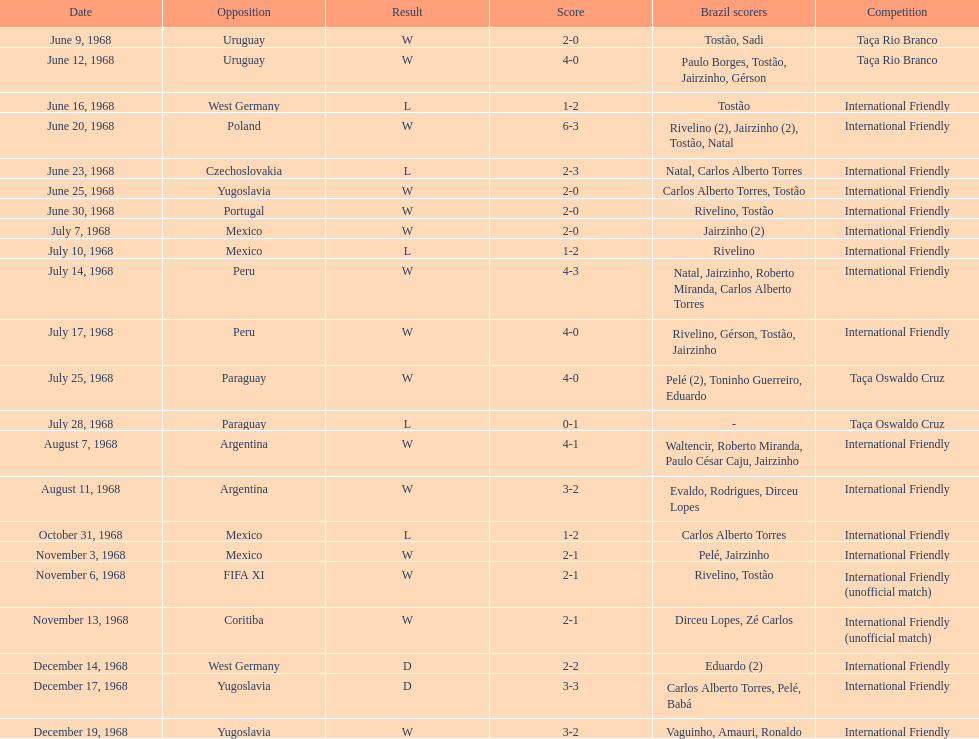Overall amount of triumphs 15. Could you parse the entire table? {'header': ['Date', 'Opposition', 'Result', 'Score', 'Brazil scorers', 'Competition'], 'rows': [['June 9, 1968', 'Uruguay', 'W', '2-0', 'Tostão, Sadi', 'Taça Rio Branco'], ['June 12, 1968', 'Uruguay', 'W', '4-0', 'Paulo Borges, Tostão, Jairzinho, Gérson', 'Taça Rio Branco'], ['June 16, 1968', 'West Germany', 'L', '1-2', 'Tostão', 'International Friendly'], ['June 20, 1968', 'Poland', 'W', '6-3', 'Rivelino (2), Jairzinho (2), Tostão, Natal', 'International Friendly'], ['June 23, 1968', 'Czechoslovakia', 'L', '2-3', 'Natal, Carlos Alberto Torres', 'International Friendly'], ['June 25, 1968', 'Yugoslavia', 'W', '2-0', 'Carlos Alberto Torres, Tostão', 'International Friendly'], ['June 30, 1968', 'Portugal', 'W', '2-0', 'Rivelino, Tostão', 'International Friendly'], ['July 7, 1968', 'Mexico', 'W', '2-0', 'Jairzinho (2)', 'International Friendly'], ['July 10, 1968', 'Mexico', 'L', '1-2', 'Rivelino', 'International Friendly'], ['July 14, 1968', 'Peru', 'W', '4-3', 'Natal, Jairzinho, Roberto Miranda, Carlos Alberto Torres', 'International Friendly'], ['July 17, 1968', 'Peru', 'W', '4-0', 'Rivelino, Gérson, Tostão, Jairzinho', 'International Friendly'], ['July 25, 1968', 'Paraguay', 'W', '4-0', 'Pelé (2), Toninho Guerreiro, Eduardo', 'Taça Oswaldo Cruz'], ['July 28, 1968', 'Paraguay', 'L', '0-1', '-', 'Taça Oswaldo Cruz'], ['August 7, 1968', 'Argentina', 'W', '4-1', 'Waltencir, Roberto Miranda, Paulo César Caju, Jairzinho', 'International Friendly'], ['August 11, 1968', 'Argentina', 'W', '3-2', 'Evaldo, Rodrigues, Dirceu Lopes', 'International Friendly'], ['October 31, 1968', 'Mexico', 'L', '1-2', 'Carlos Alberto Torres', 'International Friendly'], ['November 3, 1968', 'Mexico', 'W', '2-1', 'Pelé, Jairzinho', 'International Friendly'], ['November 6, 1968', 'FIFA XI', 'W', '2-1', 'Rivelino, Tostão', 'International Friendly (unofficial match)'], ['November 13, 1968', 'Coritiba', 'W', '2-1', 'Dirceu Lopes, Zé Carlos', 'International Friendly (unofficial match)'], ['December 14, 1968', 'West Germany', 'D', '2-2', 'Eduardo (2)', 'International Friendly'], ['December 17, 1968', 'Yugoslavia', 'D', '3-3', 'Carlos Alberto Torres, Pelé, Babá', 'International Friendly'], ['December 19, 1968', 'Yugoslavia', 'W', '3-2', 'Vaguinho, Amauri, Ronaldo', 'International Friendly']]} 